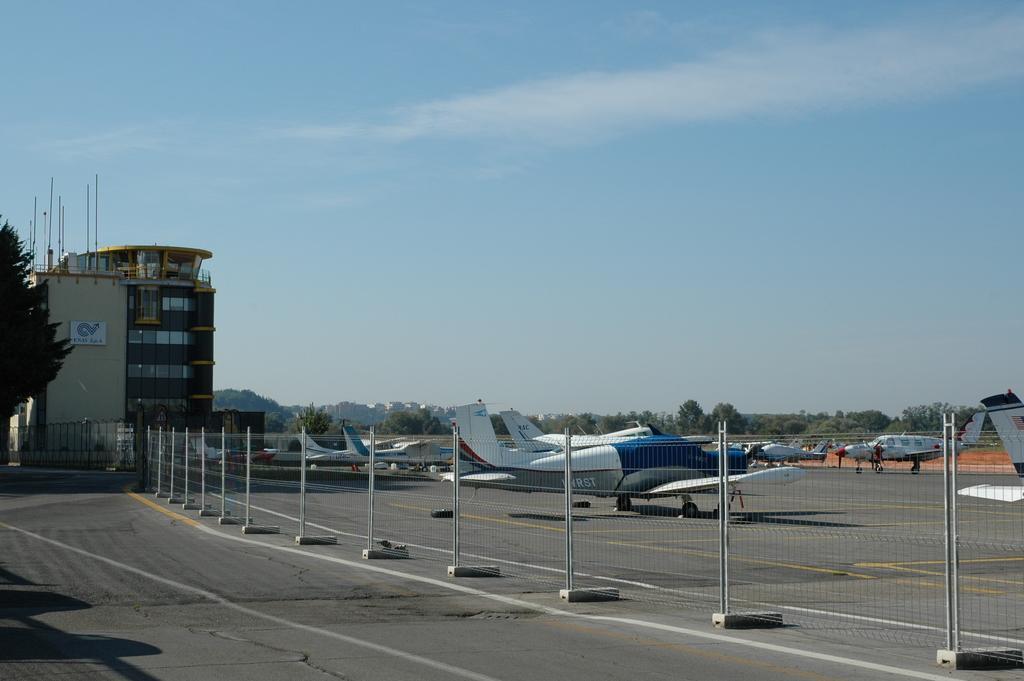How would you summarize this image in a sentence or two? In this image I can see a fence visible on road , beside the fence I can see flights and I can see building and tree on the left side ,at the top I can see the sky. 